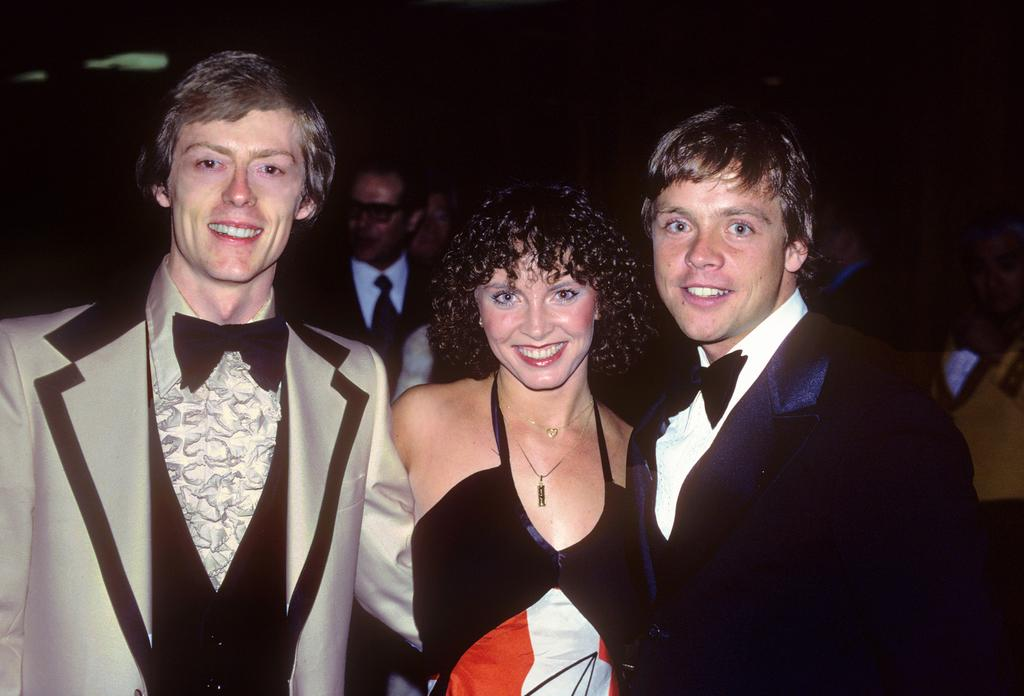How many people are present in the image? There are three people standing in the image. What are the three people doing? The three people are watching and smiling. Can you describe the background of the image? The background has a dark view. Are there any other people visible in the image besides the three main subjects? Yes, there are other people visible in the background of the image. What type of duck can be seen in the image? There is no duck present in the image. What observation can be made about the birth of the three people in the image? The image does not provide any information about the birth of the three people, and therefore no such observation can be made. 